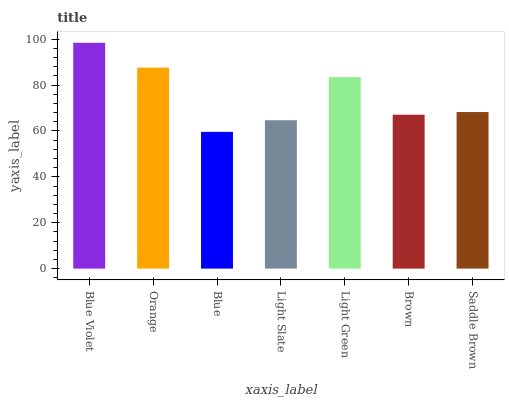Is Blue the minimum?
Answer yes or no. Yes. Is Blue Violet the maximum?
Answer yes or no. Yes. Is Orange the minimum?
Answer yes or no. No. Is Orange the maximum?
Answer yes or no. No. Is Blue Violet greater than Orange?
Answer yes or no. Yes. Is Orange less than Blue Violet?
Answer yes or no. Yes. Is Orange greater than Blue Violet?
Answer yes or no. No. Is Blue Violet less than Orange?
Answer yes or no. No. Is Saddle Brown the high median?
Answer yes or no. Yes. Is Saddle Brown the low median?
Answer yes or no. Yes. Is Light Slate the high median?
Answer yes or no. No. Is Brown the low median?
Answer yes or no. No. 